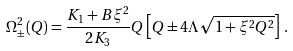Convert formula to latex. <formula><loc_0><loc_0><loc_500><loc_500>\Omega ^ { 2 } _ { \pm } ( Q ) = \frac { K _ { 1 } + B \xi ^ { 2 } } { 2 K _ { 3 } } Q \left [ Q \pm 4 \Lambda \sqrt { 1 + \xi ^ { 2 } Q ^ { 2 } } \right ] \, .</formula> 